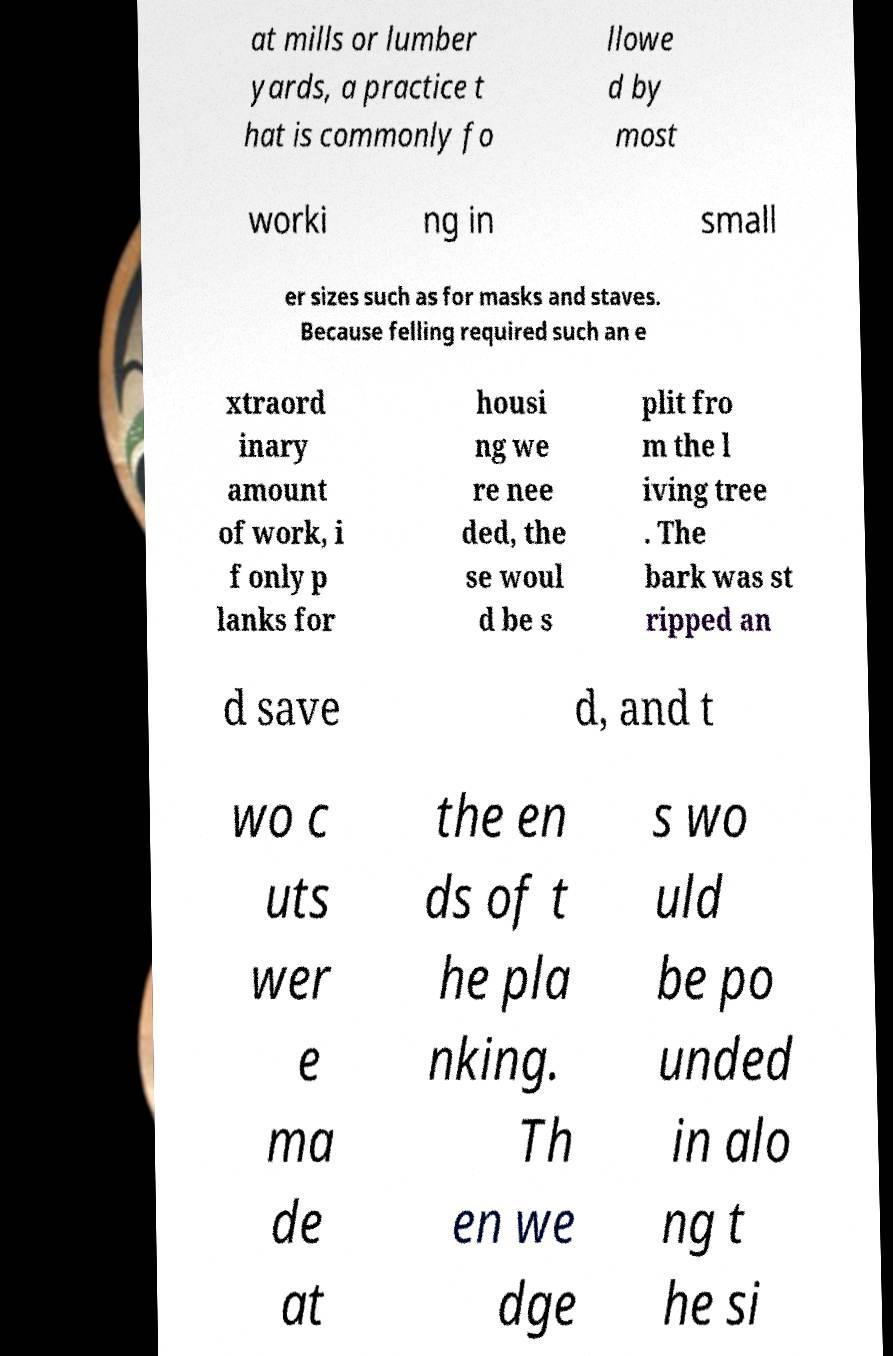Can you accurately transcribe the text from the provided image for me? at mills or lumber yards, a practice t hat is commonly fo llowe d by most worki ng in small er sizes such as for masks and staves. Because felling required such an e xtraord inary amount of work, i f only p lanks for housi ng we re nee ded, the se woul d be s plit fro m the l iving tree . The bark was st ripped an d save d, and t wo c uts wer e ma de at the en ds of t he pla nking. Th en we dge s wo uld be po unded in alo ng t he si 